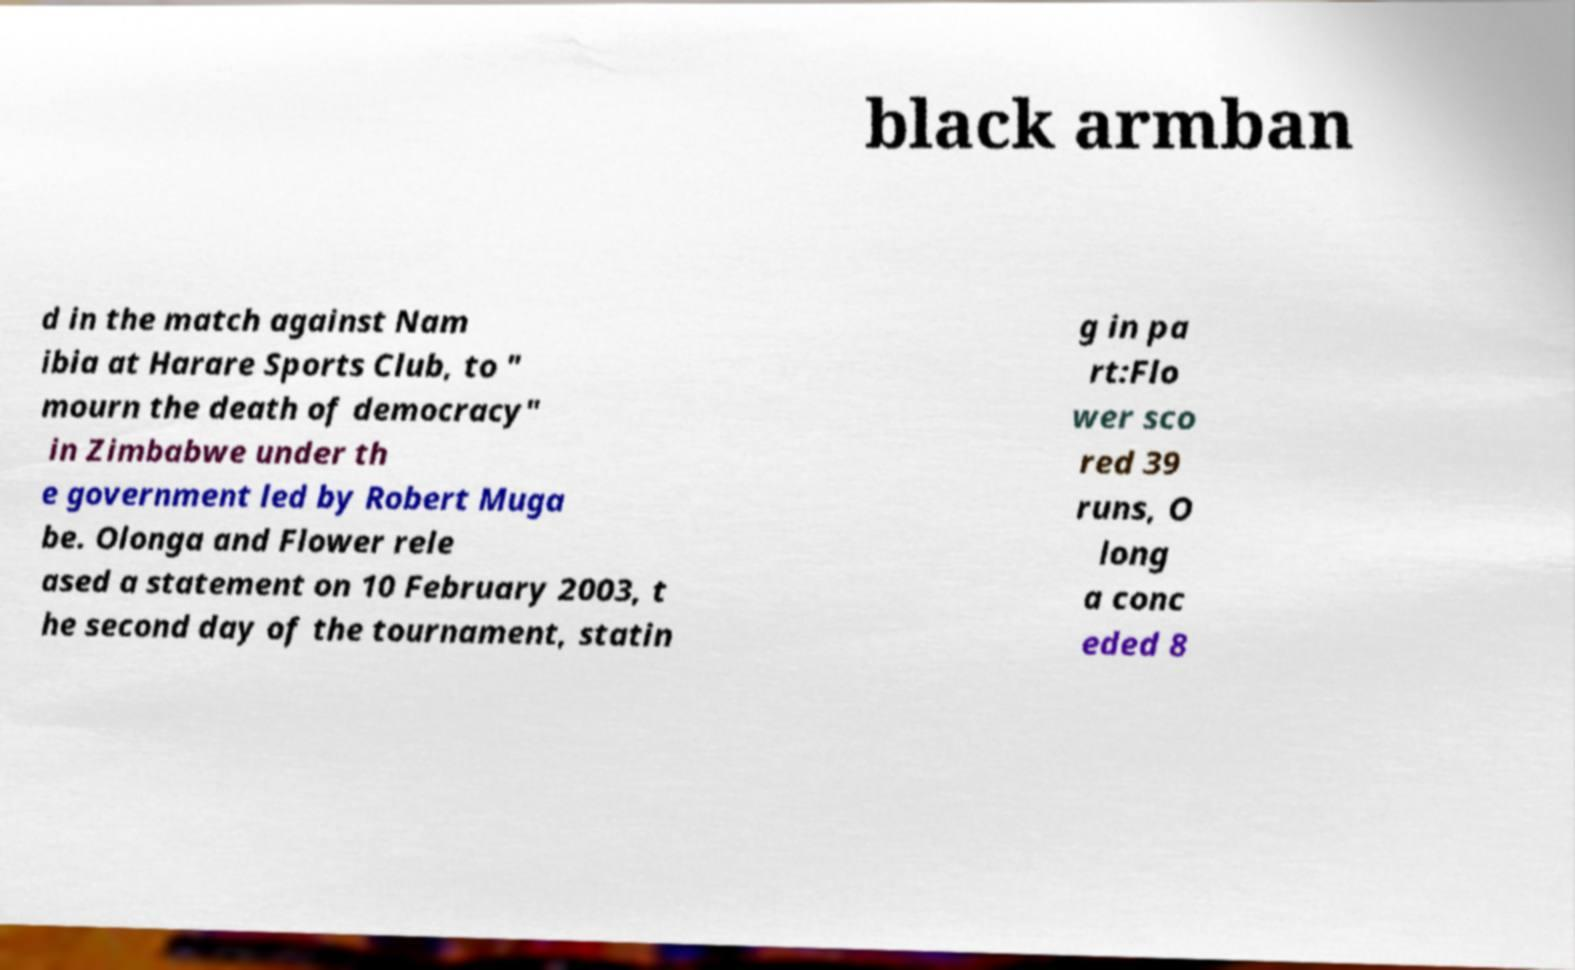Could you extract and type out the text from this image? black armban d in the match against Nam ibia at Harare Sports Club, to " mourn the death of democracy" in Zimbabwe under th e government led by Robert Muga be. Olonga and Flower rele ased a statement on 10 February 2003, t he second day of the tournament, statin g in pa rt:Flo wer sco red 39 runs, O long a conc eded 8 